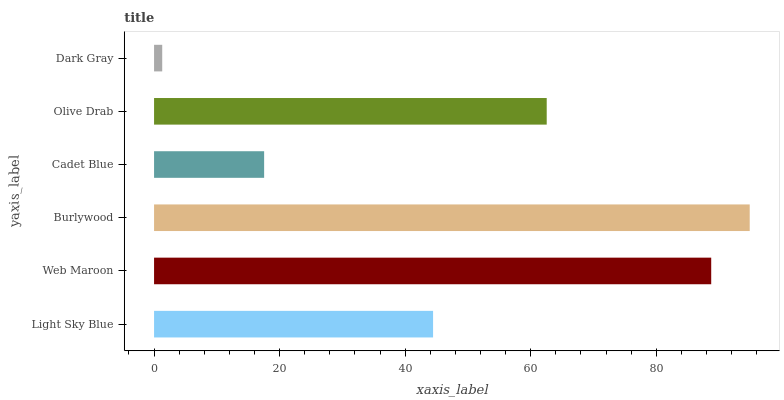Is Dark Gray the minimum?
Answer yes or no. Yes. Is Burlywood the maximum?
Answer yes or no. Yes. Is Web Maroon the minimum?
Answer yes or no. No. Is Web Maroon the maximum?
Answer yes or no. No. Is Web Maroon greater than Light Sky Blue?
Answer yes or no. Yes. Is Light Sky Blue less than Web Maroon?
Answer yes or no. Yes. Is Light Sky Blue greater than Web Maroon?
Answer yes or no. No. Is Web Maroon less than Light Sky Blue?
Answer yes or no. No. Is Olive Drab the high median?
Answer yes or no. Yes. Is Light Sky Blue the low median?
Answer yes or no. Yes. Is Burlywood the high median?
Answer yes or no. No. Is Dark Gray the low median?
Answer yes or no. No. 